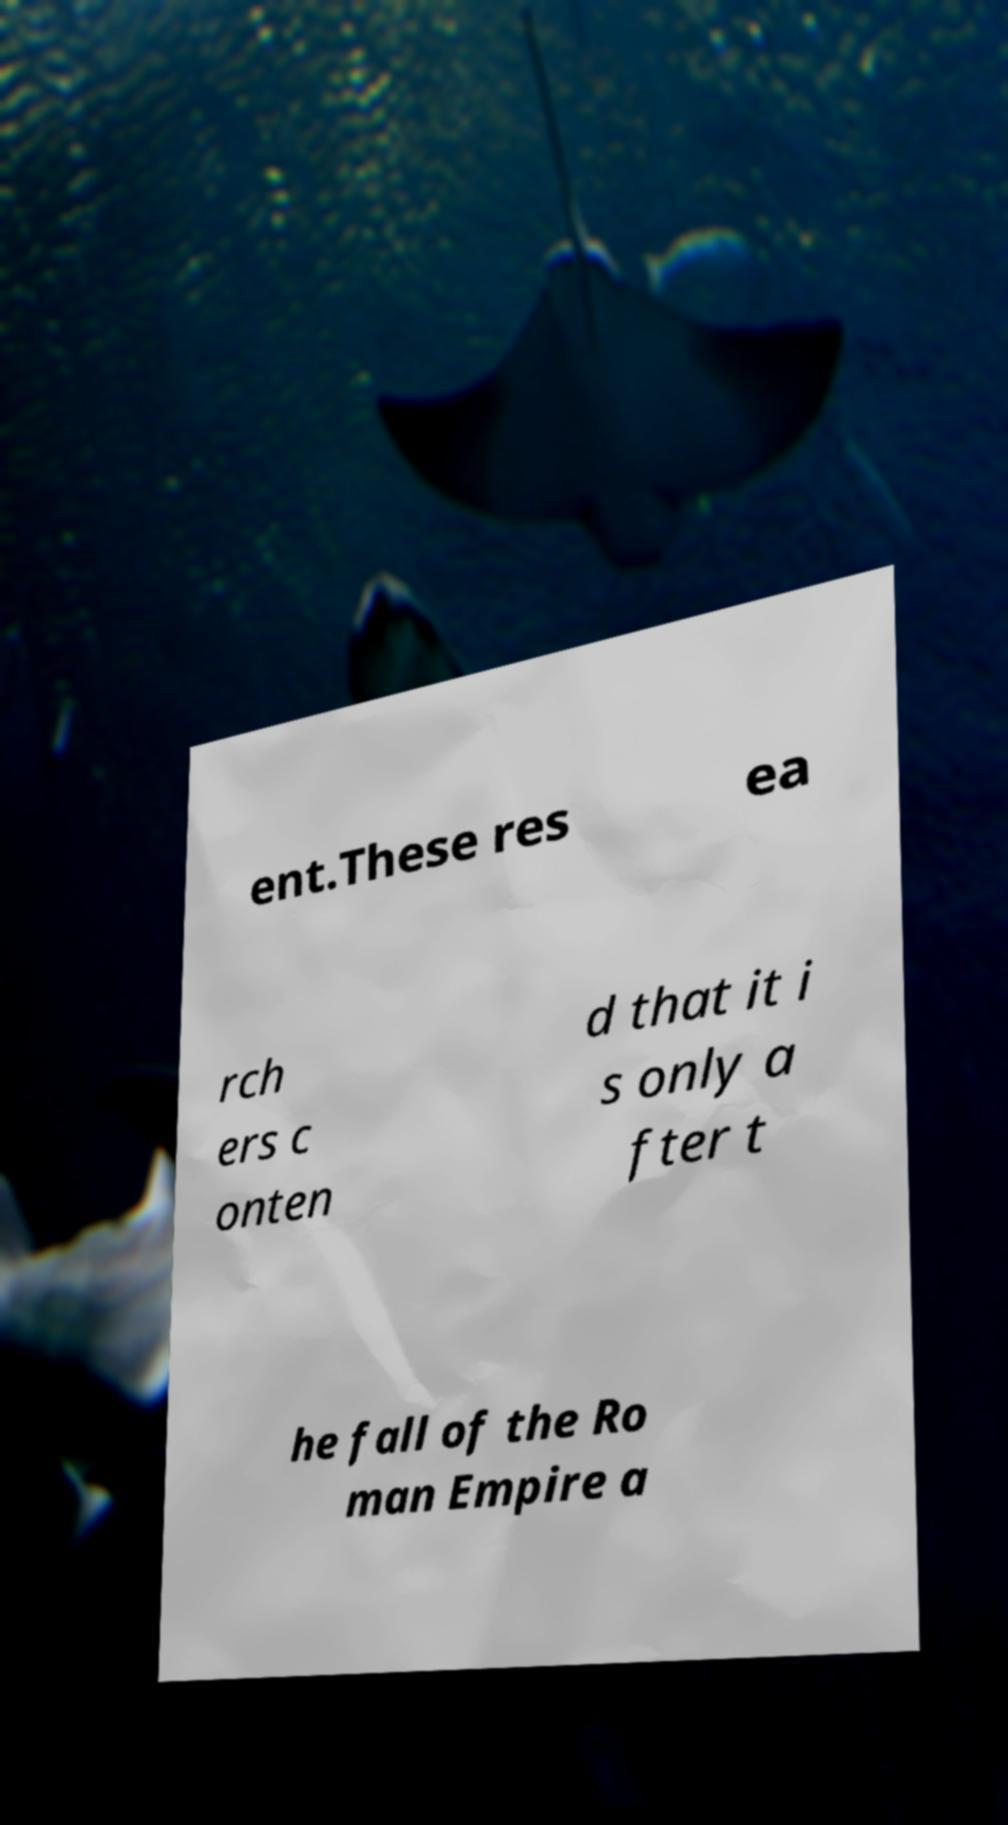For documentation purposes, I need the text within this image transcribed. Could you provide that? ent.These res ea rch ers c onten d that it i s only a fter t he fall of the Ro man Empire a 